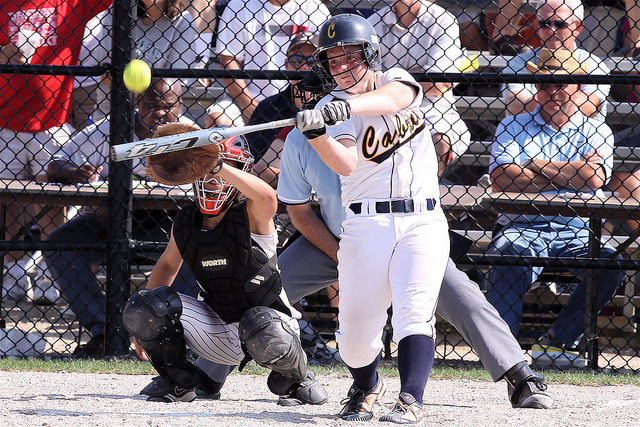What is the position of the ball in relation to the batter? The ball is positioned just in front of the batter and very close to the bat, suggesting that the batter is either about to make contact with the ball or has just done so. 